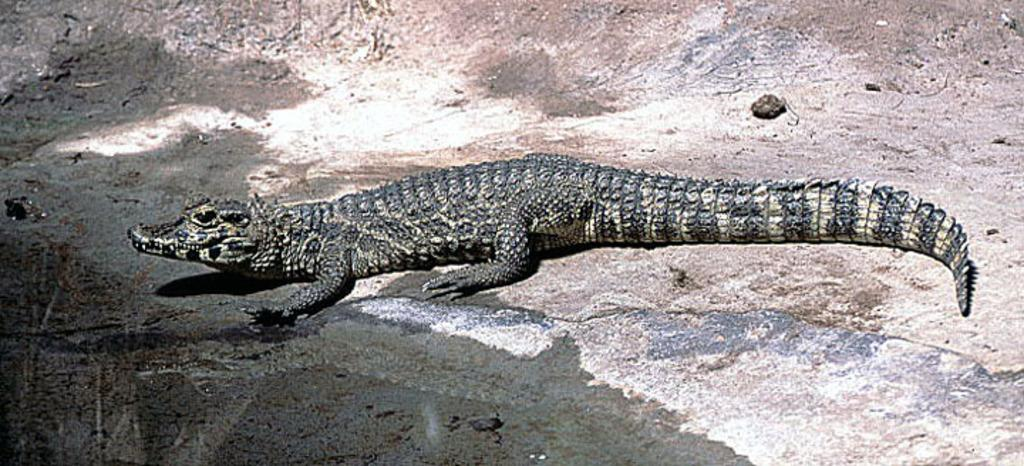What animal is present in the image? There is a crocodile in the image. Where is the crocodile located? The crocodile is on the ground. What can be seen on the left side of the image? There is water visible on the left side of the image. How many kittens are playing with the list on the right side of the image? There are no kittens or lists present in the image. 